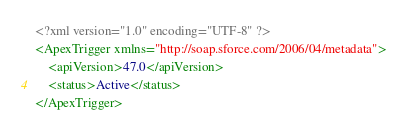Convert code to text. <code><loc_0><loc_0><loc_500><loc_500><_XML_><?xml version="1.0" encoding="UTF-8" ?>
<ApexTrigger xmlns="http://soap.sforce.com/2006/04/metadata">
    <apiVersion>47.0</apiVersion>
    <status>Active</status>
</ApexTrigger>
</code> 